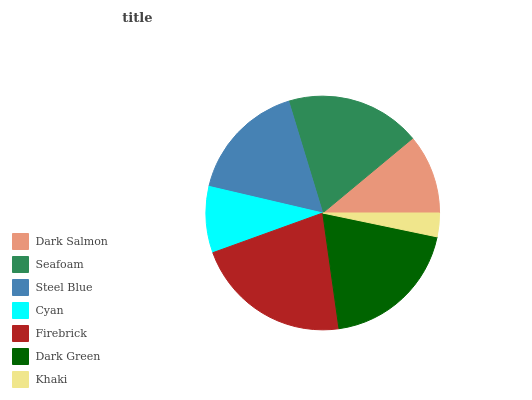Is Khaki the minimum?
Answer yes or no. Yes. Is Firebrick the maximum?
Answer yes or no. Yes. Is Seafoam the minimum?
Answer yes or no. No. Is Seafoam the maximum?
Answer yes or no. No. Is Seafoam greater than Dark Salmon?
Answer yes or no. Yes. Is Dark Salmon less than Seafoam?
Answer yes or no. Yes. Is Dark Salmon greater than Seafoam?
Answer yes or no. No. Is Seafoam less than Dark Salmon?
Answer yes or no. No. Is Steel Blue the high median?
Answer yes or no. Yes. Is Steel Blue the low median?
Answer yes or no. Yes. Is Cyan the high median?
Answer yes or no. No. Is Dark Salmon the low median?
Answer yes or no. No. 